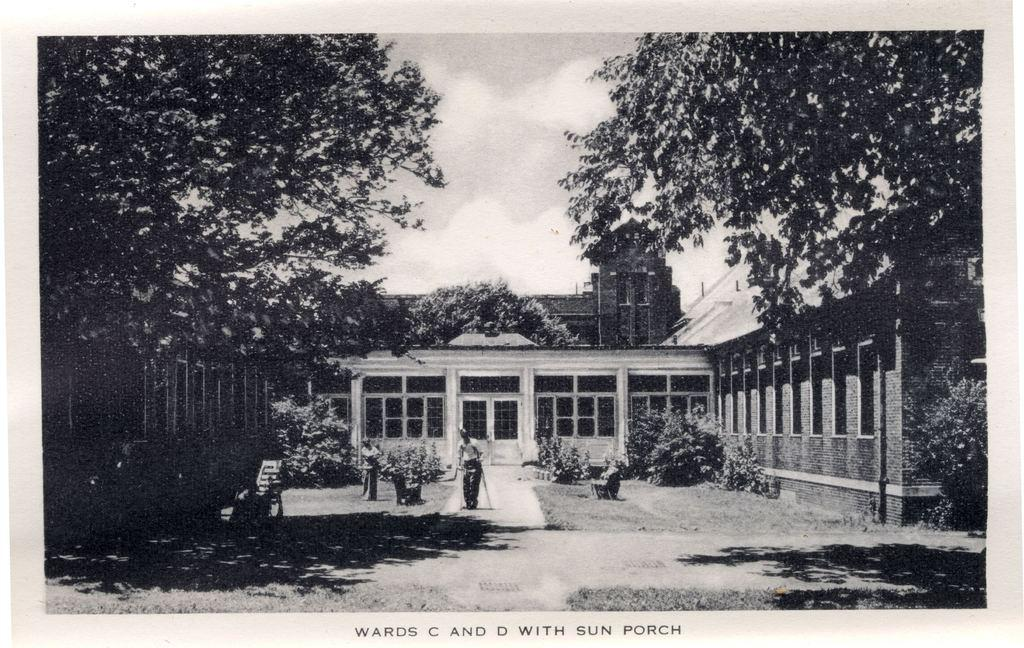<image>
Offer a succinct explanation of the picture presented. a photo of a hospital building with the caption wards c and d with sun porch 